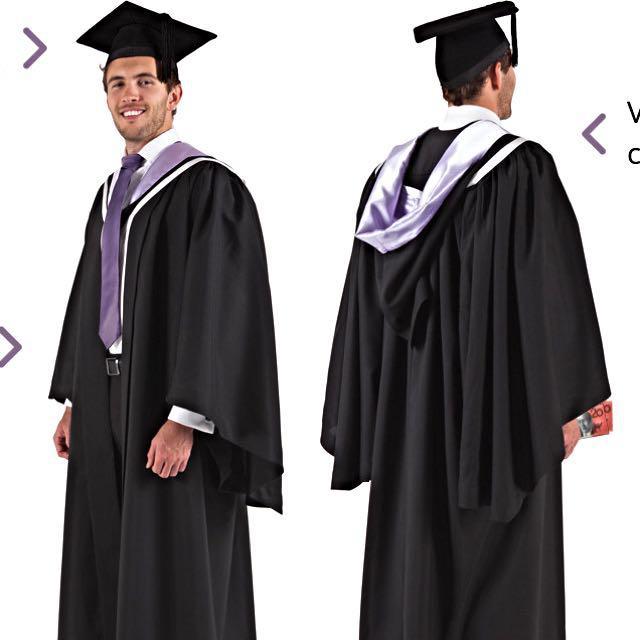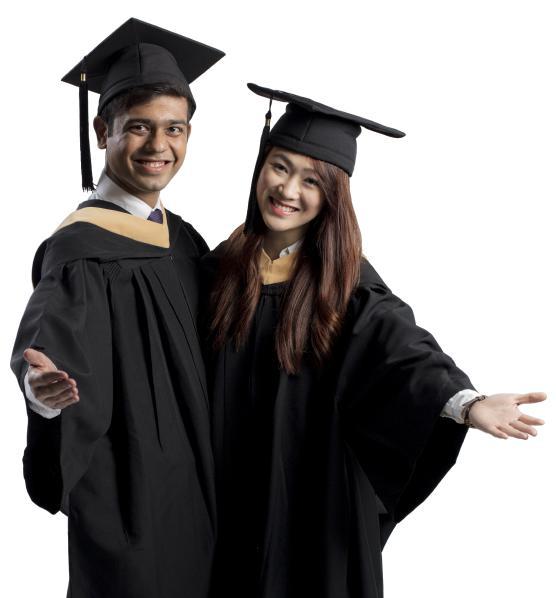The first image is the image on the left, the second image is the image on the right. Evaluate the accuracy of this statement regarding the images: "There are at least five people in total.". Is it true? Answer yes or no. No. The first image is the image on the left, the second image is the image on the right. Considering the images on both sides, is "There are atleast 5 people total" valid? Answer yes or no. No. 